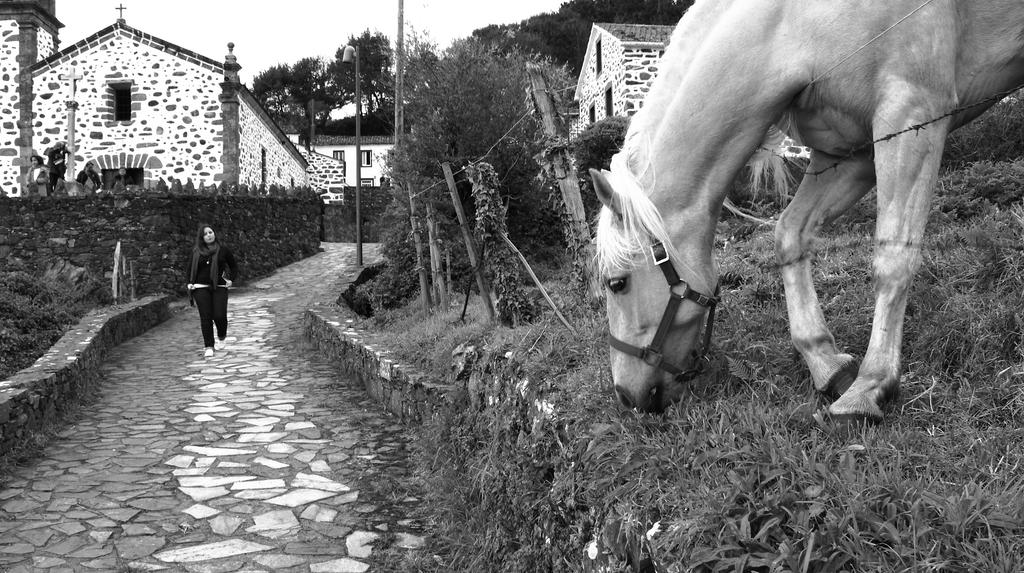What is the lady in the image doing? The lady is walking on the street. What can be seen in the top right of the image? There is a horse in the top right of the image. What is visible in the background of the image? There are buildings, trees, and poles in the background of the image. What is the condition of the sky in the image? The sky is clear in the image. How does the lady express her disgust in the image? There is no indication of the lady expressing disgust in the image. 